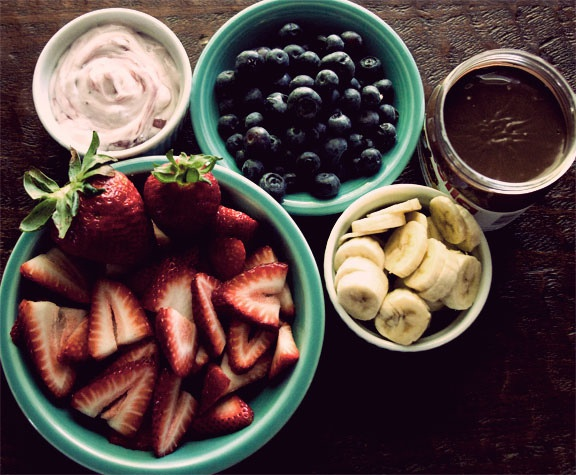Describe the objects in this image and their specific colors. I can see bowl in brown, black, maroon, and teal tones, dining table in brown, black, gray, and maroon tones, bowl in brown, black, teal, turquoise, and gray tones, bowl in brown, tan, ivory, and black tones, and bowl in brown, lightgray, and tan tones in this image. 